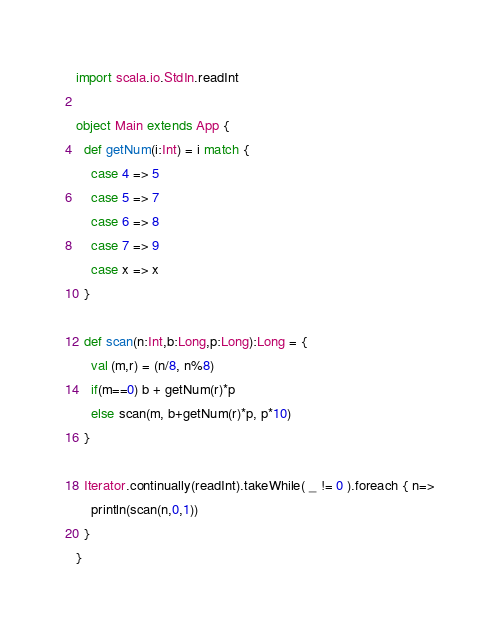<code> <loc_0><loc_0><loc_500><loc_500><_Scala_>import scala.io.StdIn.readInt

object Main extends App {
  def getNum(i:Int) = i match {
    case 4 => 5
    case 5 => 7
    case 6 => 8
    case 7 => 9
    case x => x
  }

  def scan(n:Int,b:Long,p:Long):Long = {
    val (m,r) = (n/8, n%8)
    if(m==0) b + getNum(r)*p
    else scan(m, b+getNum(r)*p, p*10)
  }

  Iterator.continually(readInt).takeWhile( _ != 0 ).foreach { n=>
    println(scan(n,0,1))
  }
}</code> 